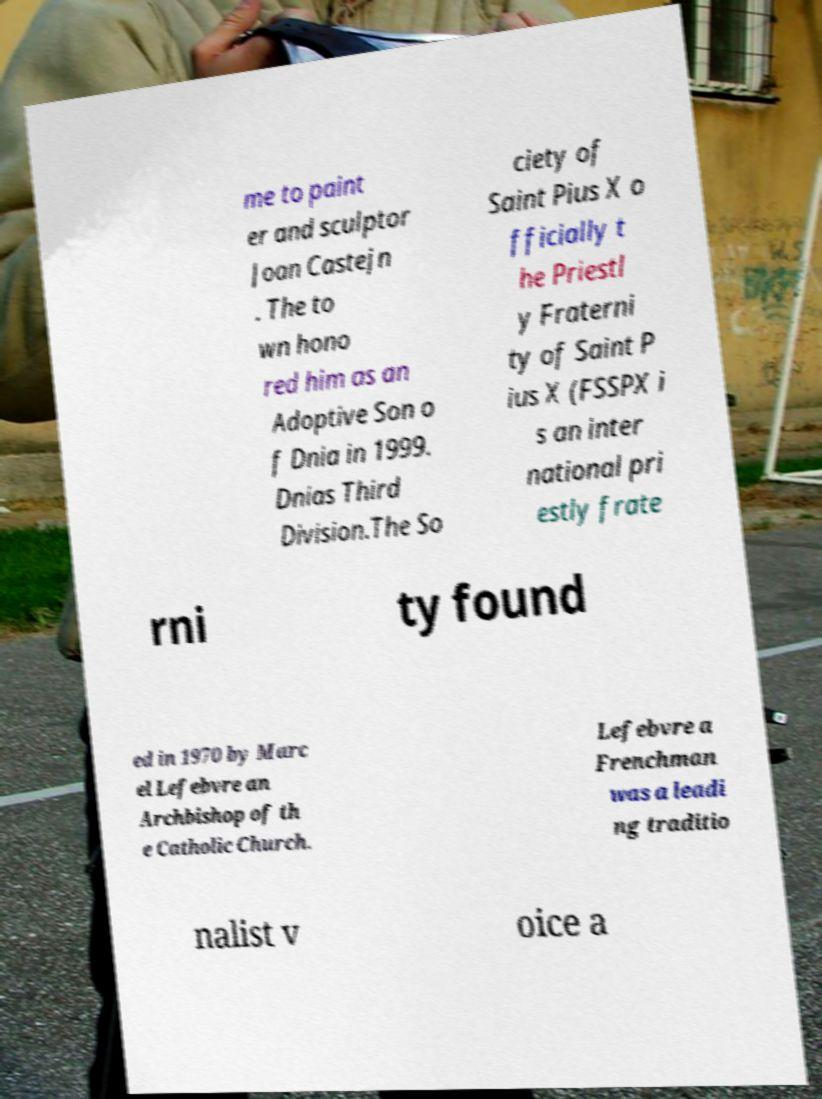For documentation purposes, I need the text within this image transcribed. Could you provide that? me to paint er and sculptor Joan Castejn . The to wn hono red him as an Adoptive Son o f Dnia in 1999. Dnias Third Division.The So ciety of Saint Pius X o fficially t he Priestl y Fraterni ty of Saint P ius X (FSSPX i s an inter national pri estly frate rni ty found ed in 1970 by Marc el Lefebvre an Archbishop of th e Catholic Church. Lefebvre a Frenchman was a leadi ng traditio nalist v oice a 